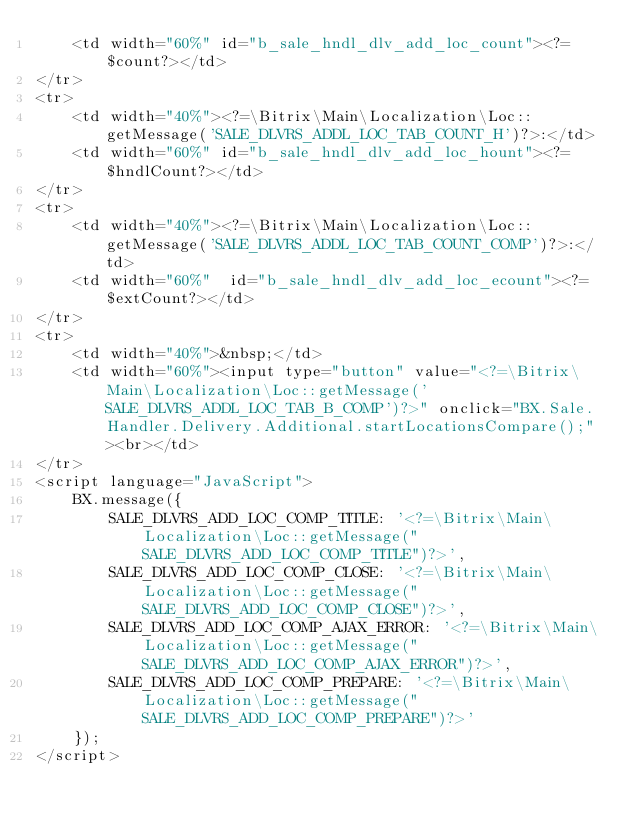<code> <loc_0><loc_0><loc_500><loc_500><_PHP_>	<td width="60%" id="b_sale_hndl_dlv_add_loc_count"><?=$count?></td>
</tr>
<tr>
	<td width="40%"><?=\Bitrix\Main\Localization\Loc::getMessage('SALE_DLVRS_ADDL_LOC_TAB_COUNT_H')?>:</td>
	<td width="60%" id="b_sale_hndl_dlv_add_loc_hount"><?=$hndlCount?></td>
</tr>
<tr>
	<td width="40%"><?=\Bitrix\Main\Localization\Loc::getMessage('SALE_DLVRS_ADDL_LOC_TAB_COUNT_COMP')?>:</td>
	<td width="60%"  id="b_sale_hndl_dlv_add_loc_ecount"><?=$extCount?></td>
</tr>
<tr>
	<td width="40%">&nbsp;</td>
	<td width="60%"><input type="button" value="<?=\Bitrix\Main\Localization\Loc::getMessage('SALE_DLVRS_ADDL_LOC_TAB_B_COMP')?>" onclick="BX.Sale.Handler.Delivery.Additional.startLocationsCompare();"><br></td>
</tr>
<script language="JavaScript">
	BX.message({
		SALE_DLVRS_ADD_LOC_COMP_TITLE: '<?=\Bitrix\Main\Localization\Loc::getMessage("SALE_DLVRS_ADD_LOC_COMP_TITLE")?>',
		SALE_DLVRS_ADD_LOC_COMP_CLOSE: '<?=\Bitrix\Main\Localization\Loc::getMessage("SALE_DLVRS_ADD_LOC_COMP_CLOSE")?>',
		SALE_DLVRS_ADD_LOC_COMP_AJAX_ERROR: '<?=\Bitrix\Main\Localization\Loc::getMessage("SALE_DLVRS_ADD_LOC_COMP_AJAX_ERROR")?>',
		SALE_DLVRS_ADD_LOC_COMP_PREPARE: '<?=\Bitrix\Main\Localization\Loc::getMessage("SALE_DLVRS_ADD_LOC_COMP_PREPARE")?>'
	});
</script>
</code> 